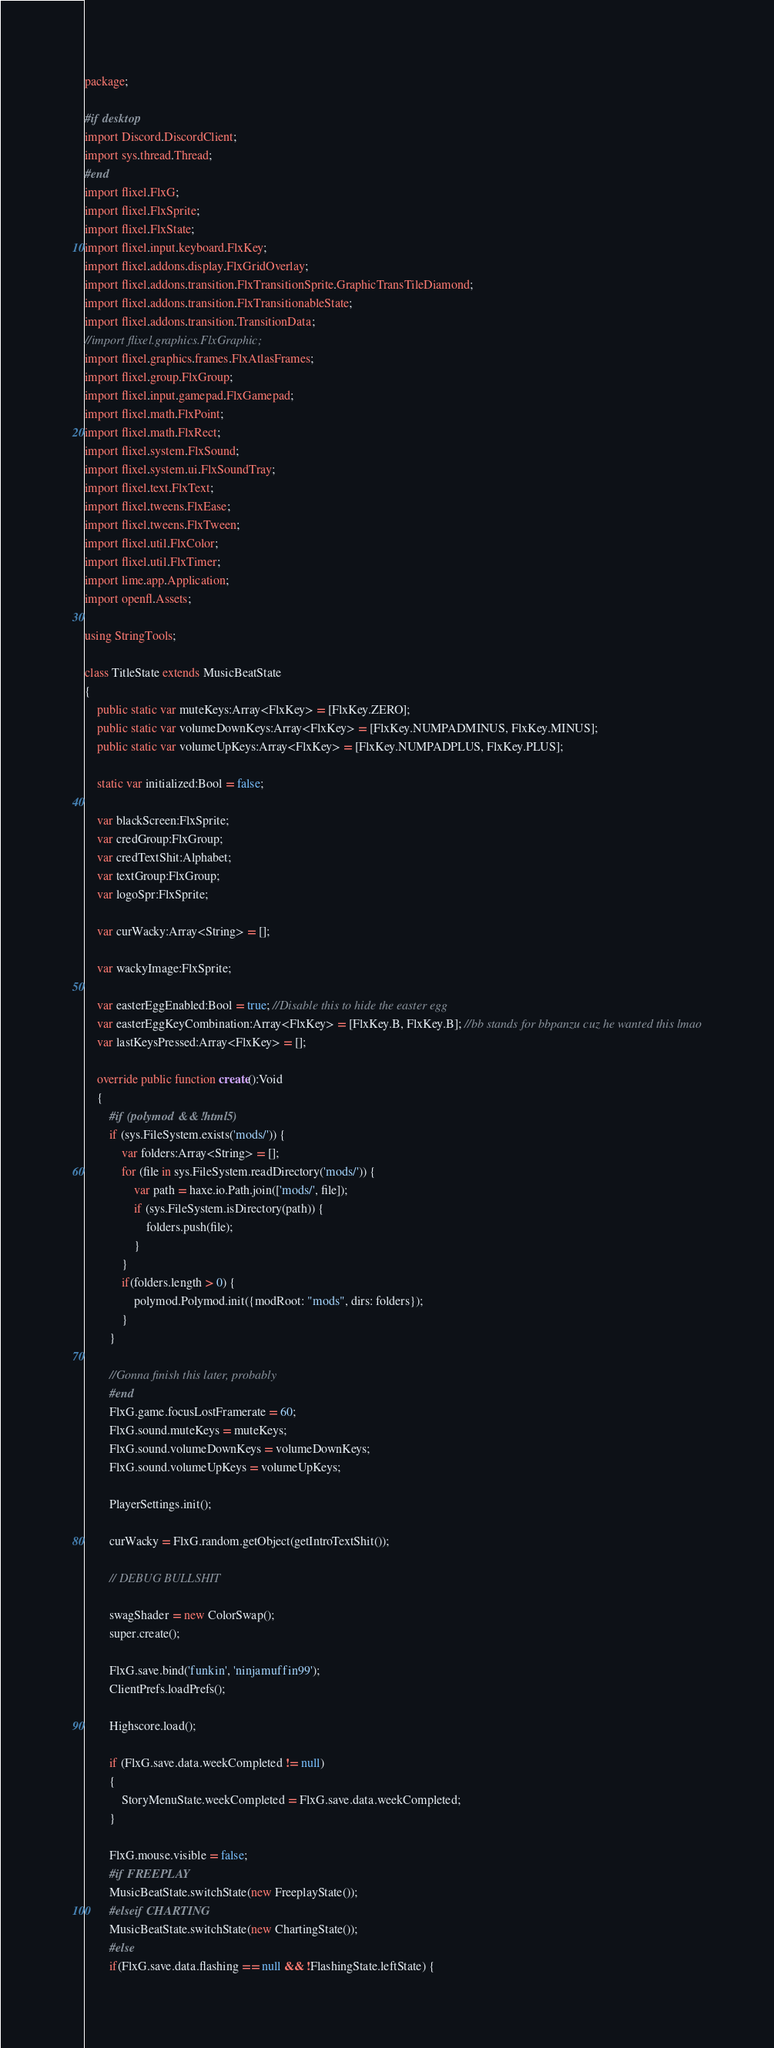<code> <loc_0><loc_0><loc_500><loc_500><_Haxe_>package;

#if desktop
import Discord.DiscordClient;
import sys.thread.Thread;
#end
import flixel.FlxG;
import flixel.FlxSprite;
import flixel.FlxState;
import flixel.input.keyboard.FlxKey;
import flixel.addons.display.FlxGridOverlay;
import flixel.addons.transition.FlxTransitionSprite.GraphicTransTileDiamond;
import flixel.addons.transition.FlxTransitionableState;
import flixel.addons.transition.TransitionData;
//import flixel.graphics.FlxGraphic;
import flixel.graphics.frames.FlxAtlasFrames;
import flixel.group.FlxGroup;
import flixel.input.gamepad.FlxGamepad;
import flixel.math.FlxPoint;
import flixel.math.FlxRect;
import flixel.system.FlxSound;
import flixel.system.ui.FlxSoundTray;
import flixel.text.FlxText;
import flixel.tweens.FlxEase;
import flixel.tweens.FlxTween;
import flixel.util.FlxColor;
import flixel.util.FlxTimer;
import lime.app.Application;
import openfl.Assets;

using StringTools;

class TitleState extends MusicBeatState
{
	public static var muteKeys:Array<FlxKey> = [FlxKey.ZERO];
	public static var volumeDownKeys:Array<FlxKey> = [FlxKey.NUMPADMINUS, FlxKey.MINUS];
	public static var volumeUpKeys:Array<FlxKey> = [FlxKey.NUMPADPLUS, FlxKey.PLUS];

	static var initialized:Bool = false;

	var blackScreen:FlxSprite;
	var credGroup:FlxGroup;
	var credTextShit:Alphabet;
	var textGroup:FlxGroup;
	var logoSpr:FlxSprite;

	var curWacky:Array<String> = [];

	var wackyImage:FlxSprite;

	var easterEggEnabled:Bool = true; //Disable this to hide the easter egg
	var easterEggKeyCombination:Array<FlxKey> = [FlxKey.B, FlxKey.B]; //bb stands for bbpanzu cuz he wanted this lmao
	var lastKeysPressed:Array<FlxKey> = [];

	override public function create():Void
	{
		#if (polymod && !html5)
		if (sys.FileSystem.exists('mods/')) {
			var folders:Array<String> = [];
			for (file in sys.FileSystem.readDirectory('mods/')) {
				var path = haxe.io.Path.join(['mods/', file]);
				if (sys.FileSystem.isDirectory(path)) {
					folders.push(file);
				}
			}
			if(folders.length > 0) {
				polymod.Polymod.init({modRoot: "mods", dirs: folders});
			}
		}

		//Gonna finish this later, probably
		#end
		FlxG.game.focusLostFramerate = 60;
		FlxG.sound.muteKeys = muteKeys;
		FlxG.sound.volumeDownKeys = volumeDownKeys;
		FlxG.sound.volumeUpKeys = volumeUpKeys;

		PlayerSettings.init();

		curWacky = FlxG.random.getObject(getIntroTextShit());

		// DEBUG BULLSHIT

		swagShader = new ColorSwap();
		super.create();

		FlxG.save.bind('funkin', 'ninjamuffin99');
		ClientPrefs.loadPrefs();

		Highscore.load();

		if (FlxG.save.data.weekCompleted != null)
		{
			StoryMenuState.weekCompleted = FlxG.save.data.weekCompleted;
		}

		FlxG.mouse.visible = false;
		#if FREEPLAY
		MusicBeatState.switchState(new FreeplayState());
		#elseif CHARTING
		MusicBeatState.switchState(new ChartingState());
		#else
		if(FlxG.save.data.flashing == null && !FlashingState.leftState) {</code> 